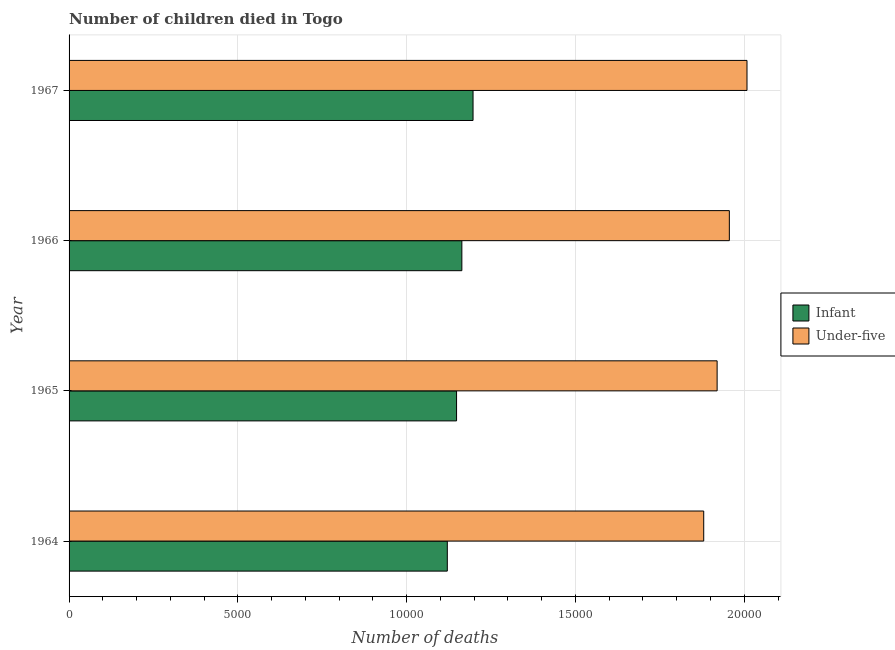How many different coloured bars are there?
Give a very brief answer. 2. How many groups of bars are there?
Keep it short and to the point. 4. Are the number of bars per tick equal to the number of legend labels?
Provide a succinct answer. Yes. Are the number of bars on each tick of the Y-axis equal?
Offer a terse response. Yes. How many bars are there on the 2nd tick from the top?
Your answer should be very brief. 2. What is the label of the 4th group of bars from the top?
Your answer should be compact. 1964. What is the number of under-five deaths in 1967?
Provide a short and direct response. 2.01e+04. Across all years, what is the maximum number of infant deaths?
Provide a short and direct response. 1.20e+04. Across all years, what is the minimum number of under-five deaths?
Keep it short and to the point. 1.88e+04. In which year was the number of under-five deaths maximum?
Provide a short and direct response. 1967. In which year was the number of infant deaths minimum?
Make the answer very short. 1964. What is the total number of under-five deaths in the graph?
Offer a very short reply. 7.76e+04. What is the difference between the number of under-five deaths in 1966 and that in 1967?
Provide a succinct answer. -523. What is the difference between the number of under-five deaths in 1966 and the number of infant deaths in 1967?
Offer a terse response. 7592. What is the average number of infant deaths per year?
Keep it short and to the point. 1.16e+04. In the year 1965, what is the difference between the number of infant deaths and number of under-five deaths?
Provide a succinct answer. -7718. What is the difference between the highest and the second highest number of infant deaths?
Your answer should be compact. 331. What is the difference between the highest and the lowest number of under-five deaths?
Keep it short and to the point. 1282. In how many years, is the number of under-five deaths greater than the average number of under-five deaths taken over all years?
Give a very brief answer. 2. What does the 1st bar from the top in 1964 represents?
Your answer should be compact. Under-five. What does the 2nd bar from the bottom in 1967 represents?
Provide a short and direct response. Under-five. How many bars are there?
Offer a terse response. 8. Are all the bars in the graph horizontal?
Keep it short and to the point. Yes. How many years are there in the graph?
Provide a short and direct response. 4. What is the difference between two consecutive major ticks on the X-axis?
Keep it short and to the point. 5000. Are the values on the major ticks of X-axis written in scientific E-notation?
Offer a terse response. No. Does the graph contain any zero values?
Your answer should be very brief. No. Does the graph contain grids?
Give a very brief answer. Yes. Where does the legend appear in the graph?
Offer a very short reply. Center right. How many legend labels are there?
Give a very brief answer. 2. How are the legend labels stacked?
Keep it short and to the point. Vertical. What is the title of the graph?
Offer a terse response. Number of children died in Togo. What is the label or title of the X-axis?
Ensure brevity in your answer.  Number of deaths. What is the label or title of the Y-axis?
Ensure brevity in your answer.  Year. What is the Number of deaths in Infant in 1964?
Provide a succinct answer. 1.12e+04. What is the Number of deaths in Under-five in 1964?
Provide a succinct answer. 1.88e+04. What is the Number of deaths in Infant in 1965?
Make the answer very short. 1.15e+04. What is the Number of deaths in Under-five in 1965?
Give a very brief answer. 1.92e+04. What is the Number of deaths in Infant in 1966?
Your answer should be compact. 1.16e+04. What is the Number of deaths of Under-five in 1966?
Offer a terse response. 1.96e+04. What is the Number of deaths of Infant in 1967?
Ensure brevity in your answer.  1.20e+04. What is the Number of deaths in Under-five in 1967?
Offer a very short reply. 2.01e+04. Across all years, what is the maximum Number of deaths of Infant?
Your response must be concise. 1.20e+04. Across all years, what is the maximum Number of deaths of Under-five?
Offer a very short reply. 2.01e+04. Across all years, what is the minimum Number of deaths in Infant?
Your answer should be very brief. 1.12e+04. Across all years, what is the minimum Number of deaths in Under-five?
Your answer should be compact. 1.88e+04. What is the total Number of deaths of Infant in the graph?
Keep it short and to the point. 4.63e+04. What is the total Number of deaths of Under-five in the graph?
Make the answer very short. 7.76e+04. What is the difference between the Number of deaths of Infant in 1964 and that in 1965?
Your answer should be very brief. -274. What is the difference between the Number of deaths in Under-five in 1964 and that in 1965?
Give a very brief answer. -397. What is the difference between the Number of deaths in Infant in 1964 and that in 1966?
Offer a terse response. -431. What is the difference between the Number of deaths of Under-five in 1964 and that in 1966?
Make the answer very short. -759. What is the difference between the Number of deaths in Infant in 1964 and that in 1967?
Provide a short and direct response. -762. What is the difference between the Number of deaths in Under-five in 1964 and that in 1967?
Your answer should be compact. -1282. What is the difference between the Number of deaths in Infant in 1965 and that in 1966?
Make the answer very short. -157. What is the difference between the Number of deaths in Under-five in 1965 and that in 1966?
Keep it short and to the point. -362. What is the difference between the Number of deaths of Infant in 1965 and that in 1967?
Ensure brevity in your answer.  -488. What is the difference between the Number of deaths of Under-five in 1965 and that in 1967?
Offer a terse response. -885. What is the difference between the Number of deaths in Infant in 1966 and that in 1967?
Offer a very short reply. -331. What is the difference between the Number of deaths of Under-five in 1966 and that in 1967?
Keep it short and to the point. -523. What is the difference between the Number of deaths of Infant in 1964 and the Number of deaths of Under-five in 1965?
Offer a terse response. -7992. What is the difference between the Number of deaths of Infant in 1964 and the Number of deaths of Under-five in 1966?
Your response must be concise. -8354. What is the difference between the Number of deaths in Infant in 1964 and the Number of deaths in Under-five in 1967?
Your answer should be compact. -8877. What is the difference between the Number of deaths in Infant in 1965 and the Number of deaths in Under-five in 1966?
Give a very brief answer. -8080. What is the difference between the Number of deaths in Infant in 1965 and the Number of deaths in Under-five in 1967?
Give a very brief answer. -8603. What is the difference between the Number of deaths in Infant in 1966 and the Number of deaths in Under-five in 1967?
Offer a very short reply. -8446. What is the average Number of deaths of Infant per year?
Ensure brevity in your answer.  1.16e+04. What is the average Number of deaths in Under-five per year?
Give a very brief answer. 1.94e+04. In the year 1964, what is the difference between the Number of deaths of Infant and Number of deaths of Under-five?
Your answer should be very brief. -7595. In the year 1965, what is the difference between the Number of deaths in Infant and Number of deaths in Under-five?
Ensure brevity in your answer.  -7718. In the year 1966, what is the difference between the Number of deaths of Infant and Number of deaths of Under-five?
Your answer should be compact. -7923. In the year 1967, what is the difference between the Number of deaths in Infant and Number of deaths in Under-five?
Your answer should be compact. -8115. What is the ratio of the Number of deaths of Infant in 1964 to that in 1965?
Make the answer very short. 0.98. What is the ratio of the Number of deaths in Under-five in 1964 to that in 1965?
Offer a terse response. 0.98. What is the ratio of the Number of deaths in Infant in 1964 to that in 1966?
Your response must be concise. 0.96. What is the ratio of the Number of deaths in Under-five in 1964 to that in 1966?
Make the answer very short. 0.96. What is the ratio of the Number of deaths of Infant in 1964 to that in 1967?
Ensure brevity in your answer.  0.94. What is the ratio of the Number of deaths in Under-five in 1964 to that in 1967?
Your answer should be compact. 0.94. What is the ratio of the Number of deaths of Infant in 1965 to that in 1966?
Offer a terse response. 0.99. What is the ratio of the Number of deaths in Under-five in 1965 to that in 1966?
Your response must be concise. 0.98. What is the ratio of the Number of deaths of Infant in 1965 to that in 1967?
Your answer should be compact. 0.96. What is the ratio of the Number of deaths in Under-five in 1965 to that in 1967?
Provide a succinct answer. 0.96. What is the ratio of the Number of deaths of Infant in 1966 to that in 1967?
Your answer should be very brief. 0.97. What is the difference between the highest and the second highest Number of deaths in Infant?
Your answer should be compact. 331. What is the difference between the highest and the second highest Number of deaths in Under-five?
Offer a terse response. 523. What is the difference between the highest and the lowest Number of deaths of Infant?
Give a very brief answer. 762. What is the difference between the highest and the lowest Number of deaths of Under-five?
Offer a terse response. 1282. 